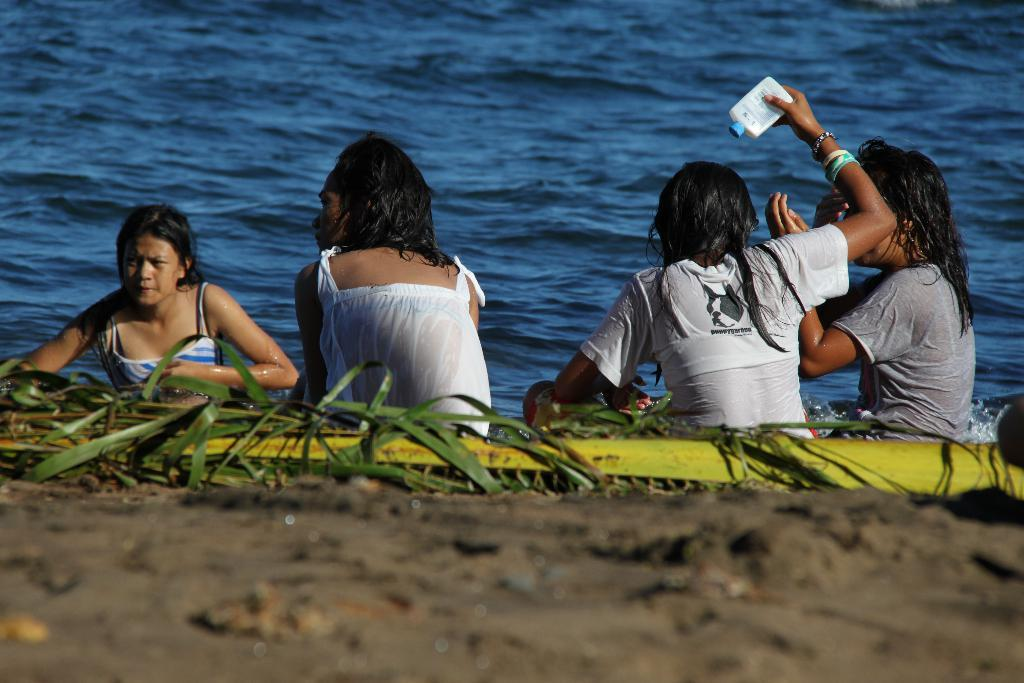How many people are in the image? There are 4 girls in the image. Where are the girls sitting in the image? The girls are sitting on the bank of a river. Who are the girls looking at in the image? The girls are looking at someone. What color is the water in the river? The water in the river is blue. What type of bear can be seen celebrating a birthday near the river in the image? There is no bear or birthday celebration present in the image. 